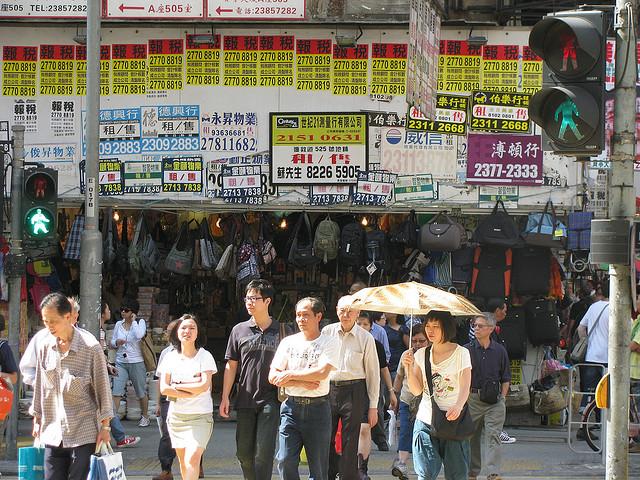Are there animals in this picture?
Keep it brief. No. What product is being sold in the background of the photo?
Short answer required. Bags. Is it sunny?
Keep it brief. Yes. 